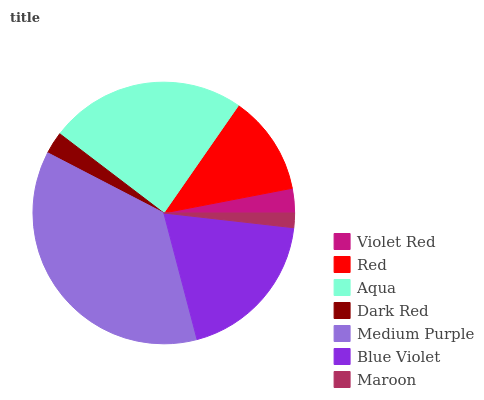Is Maroon the minimum?
Answer yes or no. Yes. Is Medium Purple the maximum?
Answer yes or no. Yes. Is Red the minimum?
Answer yes or no. No. Is Red the maximum?
Answer yes or no. No. Is Red greater than Violet Red?
Answer yes or no. Yes. Is Violet Red less than Red?
Answer yes or no. Yes. Is Violet Red greater than Red?
Answer yes or no. No. Is Red less than Violet Red?
Answer yes or no. No. Is Red the high median?
Answer yes or no. Yes. Is Red the low median?
Answer yes or no. Yes. Is Aqua the high median?
Answer yes or no. No. Is Blue Violet the low median?
Answer yes or no. No. 